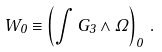Convert formula to latex. <formula><loc_0><loc_0><loc_500><loc_500>W _ { 0 } \equiv \left ( \int G _ { 3 } \wedge \Omega \right ) _ { 0 } \, .</formula> 